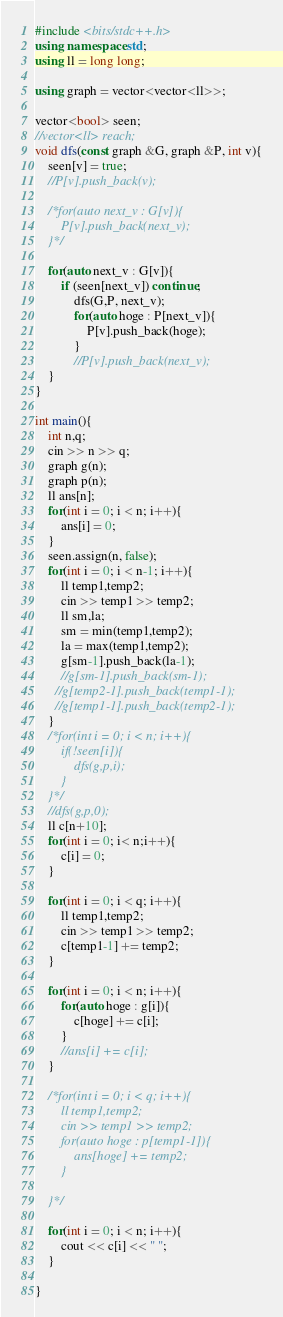<code> <loc_0><loc_0><loc_500><loc_500><_C++_>#include <bits/stdc++.h>
using namespace std;
using ll = long long;

using graph = vector<vector<ll>>;

vector<bool> seen;
//vector<ll> reach;
void dfs(const graph &G, graph &P, int v){
    seen[v] = true;
    //P[v].push_back(v);

    /*for(auto next_v : G[v]){
        P[v].push_back(next_v);
    }*/

    for(auto next_v : G[v]){
        if (seen[next_v]) continue;
            dfs(G,P, next_v);
            for(auto hoge : P[next_v]){
                P[v].push_back(hoge);
            }
            //P[v].push_back(next_v);
    }
}

int main(){
    int n,q;
    cin >> n >> q;
    graph g(n);
    graph p(n);
    ll ans[n];
    for(int i = 0; i < n; i++){
        ans[i] = 0;
    }
    seen.assign(n, false);
    for(int i = 0; i < n-1; i++){
        ll temp1,temp2;
        cin >> temp1 >> temp2;
        ll sm,la;
        sm = min(temp1,temp2);
        la = max(temp1,temp2);
        g[sm-1].push_back(la-1);
        //g[sm-1].push_back(sm-1);
      //g[temp2-1].push_back(temp1-1);
      //g[temp1-1].push_back(temp2-1);
    }
    /*for(int i = 0; i < n; i++){
        if(!seen[i]){
            dfs(g,p,i);
        }
    }*/
    //dfs(g,p,0);
    ll c[n+10];
    for(int i = 0; i< n;i++){
        c[i] = 0;
    }

    for(int i = 0; i < q; i++){
        ll temp1,temp2;
        cin >> temp1 >> temp2;
        c[temp1-1] += temp2;
    }

    for(int i = 0; i < n; i++){
        for(auto hoge : g[i]){
            c[hoge] += c[i];
        }
        //ans[i] += c[i];
    }

    /*for(int i = 0; i < q; i++){
        ll temp1,temp2;
        cin >> temp1 >> temp2;
        for(auto hoge : p[temp1-1]){
            ans[hoge] += temp2; 
        }

    }*/

    for(int i = 0; i < n; i++){
        cout << c[i] << " ";
    }

}
</code> 